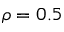<formula> <loc_0><loc_0><loc_500><loc_500>\rho = 0 . 5</formula> 